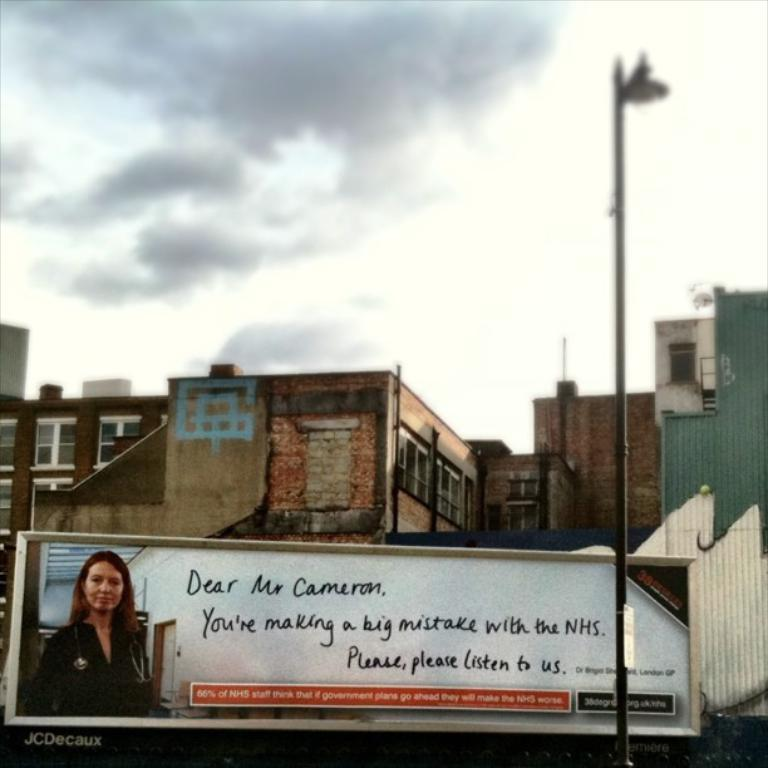What is located at the front of the image? There is a board with text and an image in the front of the image. What else can be seen at the front of the image? There is a pole in the front of the image. What is visible in the background of the image? There are buildings in the background of the image. How would you describe the sky in the background of the image? The sky is cloudy in the background of the image. What type of toothpaste is being advertised on the board in the image? There is no toothpaste present in the image. --- Facts: 1. There is a person in the image. 2. The person is wearing a hat. 3. The person is holding a book. 4. There is a tree in the background of the image. 5. The sky is visible in the background of the image. Absurd Topics: elephant, ocean, dance Conversation: Who or what is present in the image? There is a person in the image. What is the person wearing in the image? The person is wearing a hat in the image. What is the person holding in the image? The person is holding a book in the image. What can be seen in the background of the image? There is a tree in the background of the image. What else can be seen in the background of the image? The sky is visible in the background of the image. Reasoning: Let's think step by step in order to produce the conversation. We start by identifying the main subject in the image, which is the person. Next, we describe specific features of the person, such as the hat and the book they are holding. Then, we observe the background of the image, noting the presence of a tree and the sky. We formulate questions that focus on the location and characteristics of these subjects and objects, ensuring that each question can be answered definitively with the information given. We avoid yes/no questions and ensure that the language is simple and clear. Absurd Question/Answer: Can you see any elephants or oceans in the image? No, there are no elephants or oceans present in the image. --- Facts: 1. There is a group of people in the image. 2. The people are sitting on chairs. 3. There is a table in the middle of the group of people. 4. There are plates with food on the table. 5. There are glasses with drinks on the table. Absurd Topics: parachute, parrot, parsnip Conversation: How many people are present in the image? There is a group of people in the image. What are the people doing in the image? The people are sitting on chairs in the image. What is located in the middle of the group of people? There is a table in the middle of the 